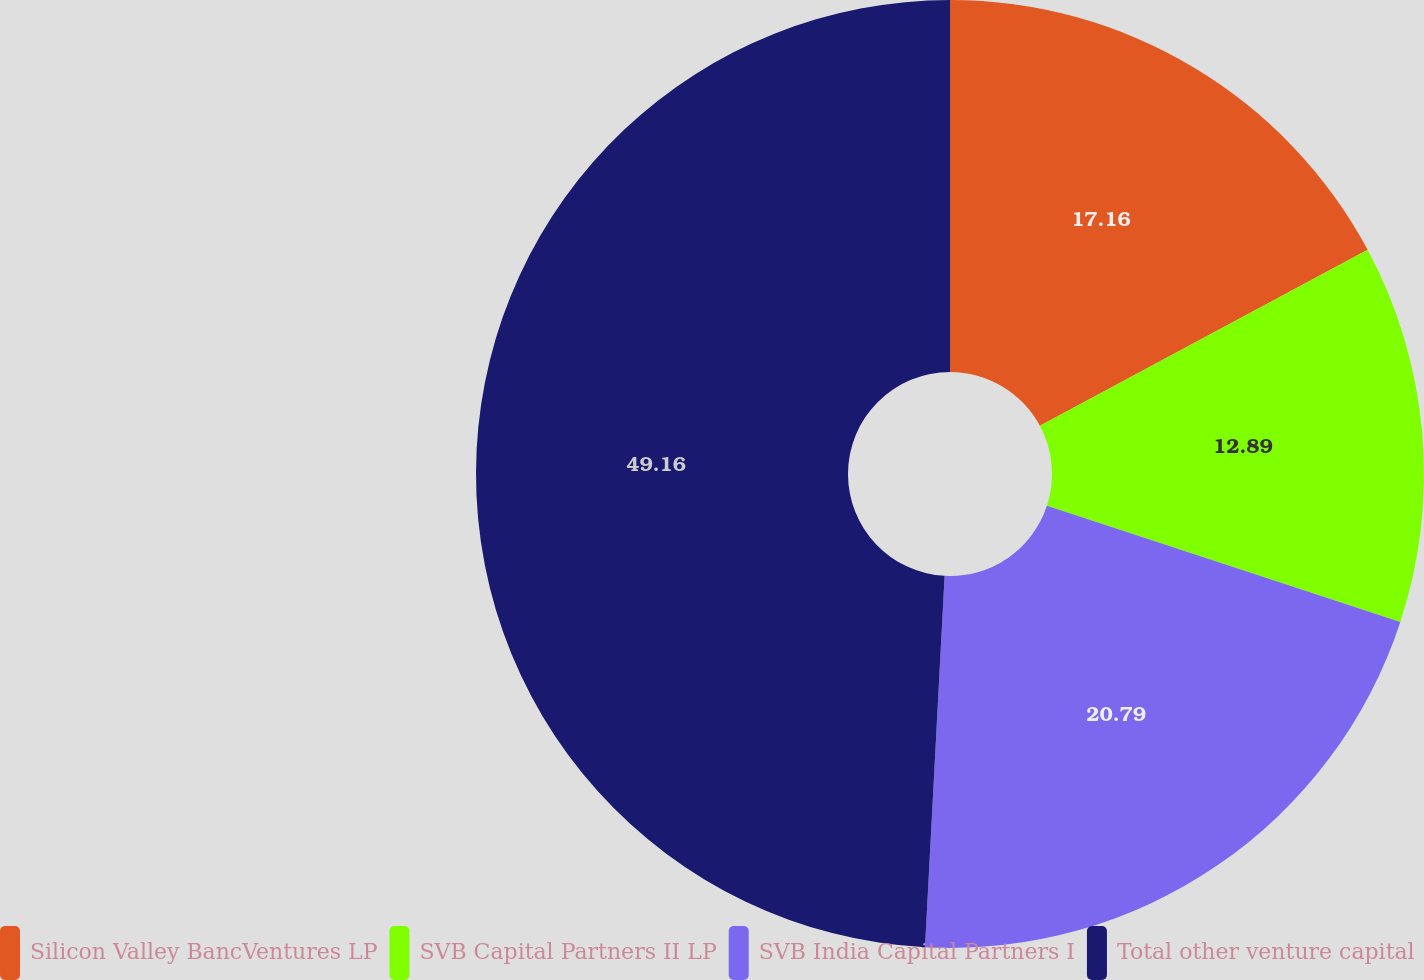<chart> <loc_0><loc_0><loc_500><loc_500><pie_chart><fcel>Silicon Valley BancVentures LP<fcel>SVB Capital Partners II LP<fcel>SVB India Capital Partners I<fcel>Total other venture capital<nl><fcel>17.16%<fcel>12.89%<fcel>20.79%<fcel>49.16%<nl></chart> 